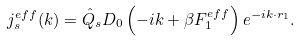<formula> <loc_0><loc_0><loc_500><loc_500>j ^ { e f f } _ { s } ( k ) = \hat { Q } _ { s } D _ { 0 } \left ( - i k + \beta F ^ { e f f } _ { 1 } \right ) e ^ { - i k \cdot r _ { 1 } } .</formula> 